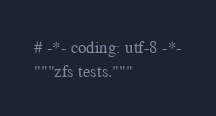<code> <loc_0><loc_0><loc_500><loc_500><_Python_># -*- coding: utf-8 -*-
"""zfs tests."""
</code> 